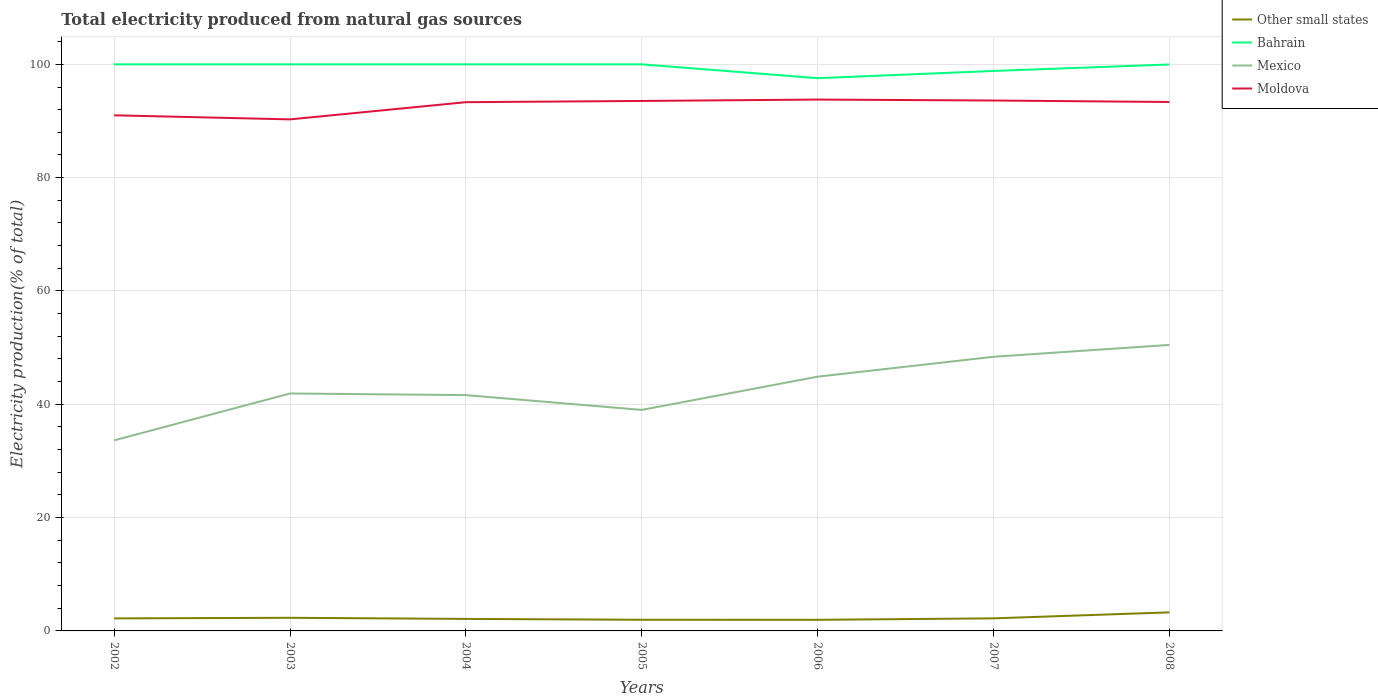Does the line corresponding to Bahrain intersect with the line corresponding to Moldova?
Offer a very short reply. No. Across all years, what is the maximum total electricity produced in Bahrain?
Your answer should be compact. 97.56. In which year was the total electricity produced in Other small states maximum?
Give a very brief answer. 2006. What is the total total electricity produced in Mexico in the graph?
Keep it short and to the point. -3.26. What is the difference between the highest and the second highest total electricity produced in Mexico?
Ensure brevity in your answer.  16.85. What is the difference between the highest and the lowest total electricity produced in Other small states?
Provide a succinct answer. 2. Is the total electricity produced in Bahrain strictly greater than the total electricity produced in Other small states over the years?
Your answer should be compact. No. How many years are there in the graph?
Provide a short and direct response. 7. Are the values on the major ticks of Y-axis written in scientific E-notation?
Your response must be concise. No. Does the graph contain any zero values?
Ensure brevity in your answer.  No. Where does the legend appear in the graph?
Provide a succinct answer. Top right. How many legend labels are there?
Make the answer very short. 4. How are the legend labels stacked?
Ensure brevity in your answer.  Vertical. What is the title of the graph?
Give a very brief answer. Total electricity produced from natural gas sources. Does "Zimbabwe" appear as one of the legend labels in the graph?
Your answer should be compact. No. What is the label or title of the X-axis?
Give a very brief answer. Years. What is the label or title of the Y-axis?
Ensure brevity in your answer.  Electricity production(% of total). What is the Electricity production(% of total) in Other small states in 2002?
Keep it short and to the point. 2.21. What is the Electricity production(% of total) of Bahrain in 2002?
Provide a short and direct response. 100. What is the Electricity production(% of total) of Mexico in 2002?
Give a very brief answer. 33.63. What is the Electricity production(% of total) in Moldova in 2002?
Your answer should be very brief. 91.01. What is the Electricity production(% of total) of Other small states in 2003?
Ensure brevity in your answer.  2.32. What is the Electricity production(% of total) in Bahrain in 2003?
Keep it short and to the point. 100. What is the Electricity production(% of total) in Mexico in 2003?
Ensure brevity in your answer.  41.91. What is the Electricity production(% of total) in Moldova in 2003?
Your answer should be very brief. 90.29. What is the Electricity production(% of total) in Other small states in 2004?
Give a very brief answer. 2.12. What is the Electricity production(% of total) in Mexico in 2004?
Keep it short and to the point. 41.62. What is the Electricity production(% of total) in Moldova in 2004?
Your answer should be very brief. 93.32. What is the Electricity production(% of total) of Other small states in 2005?
Give a very brief answer. 1.97. What is the Electricity production(% of total) in Mexico in 2005?
Give a very brief answer. 39.01. What is the Electricity production(% of total) in Moldova in 2005?
Make the answer very short. 93.54. What is the Electricity production(% of total) of Other small states in 2006?
Give a very brief answer. 1.96. What is the Electricity production(% of total) in Bahrain in 2006?
Ensure brevity in your answer.  97.56. What is the Electricity production(% of total) in Mexico in 2006?
Offer a terse response. 44.88. What is the Electricity production(% of total) of Moldova in 2006?
Provide a short and direct response. 93.78. What is the Electricity production(% of total) of Other small states in 2007?
Ensure brevity in your answer.  2.22. What is the Electricity production(% of total) of Bahrain in 2007?
Your response must be concise. 98.84. What is the Electricity production(% of total) of Mexico in 2007?
Your answer should be compact. 48.39. What is the Electricity production(% of total) in Moldova in 2007?
Provide a succinct answer. 93.62. What is the Electricity production(% of total) in Other small states in 2008?
Your answer should be compact. 3.28. What is the Electricity production(% of total) of Bahrain in 2008?
Keep it short and to the point. 99.98. What is the Electricity production(% of total) in Mexico in 2008?
Keep it short and to the point. 50.48. What is the Electricity production(% of total) of Moldova in 2008?
Keep it short and to the point. 93.36. Across all years, what is the maximum Electricity production(% of total) of Other small states?
Make the answer very short. 3.28. Across all years, what is the maximum Electricity production(% of total) in Mexico?
Provide a short and direct response. 50.48. Across all years, what is the maximum Electricity production(% of total) in Moldova?
Your answer should be compact. 93.78. Across all years, what is the minimum Electricity production(% of total) in Other small states?
Provide a short and direct response. 1.96. Across all years, what is the minimum Electricity production(% of total) in Bahrain?
Offer a very short reply. 97.56. Across all years, what is the minimum Electricity production(% of total) in Mexico?
Keep it short and to the point. 33.63. Across all years, what is the minimum Electricity production(% of total) in Moldova?
Give a very brief answer. 90.29. What is the total Electricity production(% of total) in Other small states in the graph?
Give a very brief answer. 16.07. What is the total Electricity production(% of total) in Bahrain in the graph?
Keep it short and to the point. 696.37. What is the total Electricity production(% of total) of Mexico in the graph?
Offer a terse response. 299.92. What is the total Electricity production(% of total) in Moldova in the graph?
Your response must be concise. 648.91. What is the difference between the Electricity production(% of total) of Other small states in 2002 and that in 2003?
Your answer should be compact. -0.1. What is the difference between the Electricity production(% of total) in Bahrain in 2002 and that in 2003?
Offer a very short reply. 0. What is the difference between the Electricity production(% of total) of Mexico in 2002 and that in 2003?
Keep it short and to the point. -8.28. What is the difference between the Electricity production(% of total) of Moldova in 2002 and that in 2003?
Ensure brevity in your answer.  0.72. What is the difference between the Electricity production(% of total) of Other small states in 2002 and that in 2004?
Your answer should be very brief. 0.09. What is the difference between the Electricity production(% of total) in Bahrain in 2002 and that in 2004?
Give a very brief answer. 0. What is the difference between the Electricity production(% of total) of Mexico in 2002 and that in 2004?
Make the answer very short. -7.98. What is the difference between the Electricity production(% of total) in Moldova in 2002 and that in 2004?
Provide a succinct answer. -2.32. What is the difference between the Electricity production(% of total) in Other small states in 2002 and that in 2005?
Your answer should be compact. 0.24. What is the difference between the Electricity production(% of total) of Mexico in 2002 and that in 2005?
Give a very brief answer. -5.38. What is the difference between the Electricity production(% of total) in Moldova in 2002 and that in 2005?
Your answer should be compact. -2.53. What is the difference between the Electricity production(% of total) in Other small states in 2002 and that in 2006?
Your answer should be compact. 0.25. What is the difference between the Electricity production(% of total) in Bahrain in 2002 and that in 2006?
Offer a very short reply. 2.44. What is the difference between the Electricity production(% of total) in Mexico in 2002 and that in 2006?
Keep it short and to the point. -11.24. What is the difference between the Electricity production(% of total) of Moldova in 2002 and that in 2006?
Offer a very short reply. -2.78. What is the difference between the Electricity production(% of total) of Other small states in 2002 and that in 2007?
Offer a terse response. -0.01. What is the difference between the Electricity production(% of total) of Bahrain in 2002 and that in 2007?
Your response must be concise. 1.16. What is the difference between the Electricity production(% of total) in Mexico in 2002 and that in 2007?
Provide a short and direct response. -14.75. What is the difference between the Electricity production(% of total) of Moldova in 2002 and that in 2007?
Your response must be concise. -2.61. What is the difference between the Electricity production(% of total) of Other small states in 2002 and that in 2008?
Your answer should be very brief. -1.06. What is the difference between the Electricity production(% of total) in Bahrain in 2002 and that in 2008?
Give a very brief answer. 0.02. What is the difference between the Electricity production(% of total) in Mexico in 2002 and that in 2008?
Give a very brief answer. -16.85. What is the difference between the Electricity production(% of total) in Moldova in 2002 and that in 2008?
Your answer should be very brief. -2.35. What is the difference between the Electricity production(% of total) in Other small states in 2003 and that in 2004?
Offer a terse response. 0.19. What is the difference between the Electricity production(% of total) of Mexico in 2003 and that in 2004?
Give a very brief answer. 0.29. What is the difference between the Electricity production(% of total) in Moldova in 2003 and that in 2004?
Provide a succinct answer. -3.04. What is the difference between the Electricity production(% of total) of Other small states in 2003 and that in 2005?
Offer a very short reply. 0.34. What is the difference between the Electricity production(% of total) of Bahrain in 2003 and that in 2005?
Make the answer very short. 0. What is the difference between the Electricity production(% of total) of Mexico in 2003 and that in 2005?
Offer a very short reply. 2.9. What is the difference between the Electricity production(% of total) of Moldova in 2003 and that in 2005?
Offer a very short reply. -3.25. What is the difference between the Electricity production(% of total) of Other small states in 2003 and that in 2006?
Keep it short and to the point. 0.35. What is the difference between the Electricity production(% of total) in Bahrain in 2003 and that in 2006?
Your answer should be compact. 2.44. What is the difference between the Electricity production(% of total) of Mexico in 2003 and that in 2006?
Your response must be concise. -2.96. What is the difference between the Electricity production(% of total) of Moldova in 2003 and that in 2006?
Provide a short and direct response. -3.5. What is the difference between the Electricity production(% of total) in Other small states in 2003 and that in 2007?
Ensure brevity in your answer.  0.1. What is the difference between the Electricity production(% of total) of Bahrain in 2003 and that in 2007?
Your response must be concise. 1.16. What is the difference between the Electricity production(% of total) in Mexico in 2003 and that in 2007?
Offer a very short reply. -6.48. What is the difference between the Electricity production(% of total) of Moldova in 2003 and that in 2007?
Provide a succinct answer. -3.33. What is the difference between the Electricity production(% of total) of Other small states in 2003 and that in 2008?
Provide a succinct answer. -0.96. What is the difference between the Electricity production(% of total) in Bahrain in 2003 and that in 2008?
Give a very brief answer. 0.02. What is the difference between the Electricity production(% of total) of Mexico in 2003 and that in 2008?
Keep it short and to the point. -8.57. What is the difference between the Electricity production(% of total) of Moldova in 2003 and that in 2008?
Your answer should be compact. -3.07. What is the difference between the Electricity production(% of total) of Other small states in 2004 and that in 2005?
Provide a short and direct response. 0.15. What is the difference between the Electricity production(% of total) in Mexico in 2004 and that in 2005?
Ensure brevity in your answer.  2.61. What is the difference between the Electricity production(% of total) in Moldova in 2004 and that in 2005?
Ensure brevity in your answer.  -0.22. What is the difference between the Electricity production(% of total) of Other small states in 2004 and that in 2006?
Make the answer very short. 0.16. What is the difference between the Electricity production(% of total) of Bahrain in 2004 and that in 2006?
Make the answer very short. 2.44. What is the difference between the Electricity production(% of total) of Mexico in 2004 and that in 2006?
Your answer should be very brief. -3.26. What is the difference between the Electricity production(% of total) of Moldova in 2004 and that in 2006?
Your answer should be compact. -0.46. What is the difference between the Electricity production(% of total) in Other small states in 2004 and that in 2007?
Provide a succinct answer. -0.1. What is the difference between the Electricity production(% of total) in Bahrain in 2004 and that in 2007?
Offer a very short reply. 1.16. What is the difference between the Electricity production(% of total) in Mexico in 2004 and that in 2007?
Your response must be concise. -6.77. What is the difference between the Electricity production(% of total) in Moldova in 2004 and that in 2007?
Provide a short and direct response. -0.29. What is the difference between the Electricity production(% of total) of Other small states in 2004 and that in 2008?
Give a very brief answer. -1.16. What is the difference between the Electricity production(% of total) of Bahrain in 2004 and that in 2008?
Make the answer very short. 0.02. What is the difference between the Electricity production(% of total) in Mexico in 2004 and that in 2008?
Make the answer very short. -8.86. What is the difference between the Electricity production(% of total) of Moldova in 2004 and that in 2008?
Offer a terse response. -0.03. What is the difference between the Electricity production(% of total) in Other small states in 2005 and that in 2006?
Offer a terse response. 0.01. What is the difference between the Electricity production(% of total) of Bahrain in 2005 and that in 2006?
Provide a short and direct response. 2.44. What is the difference between the Electricity production(% of total) in Mexico in 2005 and that in 2006?
Offer a terse response. -5.86. What is the difference between the Electricity production(% of total) in Moldova in 2005 and that in 2006?
Offer a very short reply. -0.24. What is the difference between the Electricity production(% of total) in Other small states in 2005 and that in 2007?
Your response must be concise. -0.25. What is the difference between the Electricity production(% of total) in Bahrain in 2005 and that in 2007?
Your answer should be very brief. 1.16. What is the difference between the Electricity production(% of total) of Mexico in 2005 and that in 2007?
Your response must be concise. -9.38. What is the difference between the Electricity production(% of total) in Moldova in 2005 and that in 2007?
Offer a very short reply. -0.08. What is the difference between the Electricity production(% of total) of Other small states in 2005 and that in 2008?
Offer a terse response. -1.31. What is the difference between the Electricity production(% of total) in Bahrain in 2005 and that in 2008?
Keep it short and to the point. 0.02. What is the difference between the Electricity production(% of total) of Mexico in 2005 and that in 2008?
Offer a very short reply. -11.47. What is the difference between the Electricity production(% of total) of Moldova in 2005 and that in 2008?
Make the answer very short. 0.18. What is the difference between the Electricity production(% of total) in Other small states in 2006 and that in 2007?
Make the answer very short. -0.26. What is the difference between the Electricity production(% of total) of Bahrain in 2006 and that in 2007?
Offer a terse response. -1.28. What is the difference between the Electricity production(% of total) in Mexico in 2006 and that in 2007?
Give a very brief answer. -3.51. What is the difference between the Electricity production(% of total) in Moldova in 2006 and that in 2007?
Ensure brevity in your answer.  0.17. What is the difference between the Electricity production(% of total) in Other small states in 2006 and that in 2008?
Your answer should be very brief. -1.31. What is the difference between the Electricity production(% of total) in Bahrain in 2006 and that in 2008?
Provide a succinct answer. -2.42. What is the difference between the Electricity production(% of total) in Mexico in 2006 and that in 2008?
Offer a very short reply. -5.61. What is the difference between the Electricity production(% of total) of Moldova in 2006 and that in 2008?
Provide a succinct answer. 0.43. What is the difference between the Electricity production(% of total) of Other small states in 2007 and that in 2008?
Make the answer very short. -1.06. What is the difference between the Electricity production(% of total) of Bahrain in 2007 and that in 2008?
Provide a succinct answer. -1.14. What is the difference between the Electricity production(% of total) of Mexico in 2007 and that in 2008?
Offer a very short reply. -2.1. What is the difference between the Electricity production(% of total) in Moldova in 2007 and that in 2008?
Give a very brief answer. 0.26. What is the difference between the Electricity production(% of total) of Other small states in 2002 and the Electricity production(% of total) of Bahrain in 2003?
Offer a very short reply. -97.79. What is the difference between the Electricity production(% of total) in Other small states in 2002 and the Electricity production(% of total) in Mexico in 2003?
Your response must be concise. -39.7. What is the difference between the Electricity production(% of total) of Other small states in 2002 and the Electricity production(% of total) of Moldova in 2003?
Provide a succinct answer. -88.07. What is the difference between the Electricity production(% of total) in Bahrain in 2002 and the Electricity production(% of total) in Mexico in 2003?
Keep it short and to the point. 58.09. What is the difference between the Electricity production(% of total) in Bahrain in 2002 and the Electricity production(% of total) in Moldova in 2003?
Give a very brief answer. 9.71. What is the difference between the Electricity production(% of total) of Mexico in 2002 and the Electricity production(% of total) of Moldova in 2003?
Keep it short and to the point. -56.65. What is the difference between the Electricity production(% of total) of Other small states in 2002 and the Electricity production(% of total) of Bahrain in 2004?
Ensure brevity in your answer.  -97.79. What is the difference between the Electricity production(% of total) of Other small states in 2002 and the Electricity production(% of total) of Mexico in 2004?
Provide a succinct answer. -39.41. What is the difference between the Electricity production(% of total) of Other small states in 2002 and the Electricity production(% of total) of Moldova in 2004?
Provide a succinct answer. -91.11. What is the difference between the Electricity production(% of total) in Bahrain in 2002 and the Electricity production(% of total) in Mexico in 2004?
Ensure brevity in your answer.  58.38. What is the difference between the Electricity production(% of total) of Bahrain in 2002 and the Electricity production(% of total) of Moldova in 2004?
Offer a very short reply. 6.68. What is the difference between the Electricity production(% of total) in Mexico in 2002 and the Electricity production(% of total) in Moldova in 2004?
Make the answer very short. -59.69. What is the difference between the Electricity production(% of total) of Other small states in 2002 and the Electricity production(% of total) of Bahrain in 2005?
Offer a terse response. -97.79. What is the difference between the Electricity production(% of total) of Other small states in 2002 and the Electricity production(% of total) of Mexico in 2005?
Offer a terse response. -36.8. What is the difference between the Electricity production(% of total) in Other small states in 2002 and the Electricity production(% of total) in Moldova in 2005?
Make the answer very short. -91.33. What is the difference between the Electricity production(% of total) in Bahrain in 2002 and the Electricity production(% of total) in Mexico in 2005?
Make the answer very short. 60.99. What is the difference between the Electricity production(% of total) in Bahrain in 2002 and the Electricity production(% of total) in Moldova in 2005?
Keep it short and to the point. 6.46. What is the difference between the Electricity production(% of total) in Mexico in 2002 and the Electricity production(% of total) in Moldova in 2005?
Ensure brevity in your answer.  -59.9. What is the difference between the Electricity production(% of total) of Other small states in 2002 and the Electricity production(% of total) of Bahrain in 2006?
Provide a short and direct response. -95.34. What is the difference between the Electricity production(% of total) in Other small states in 2002 and the Electricity production(% of total) in Mexico in 2006?
Provide a short and direct response. -42.66. What is the difference between the Electricity production(% of total) in Other small states in 2002 and the Electricity production(% of total) in Moldova in 2006?
Offer a terse response. -91.57. What is the difference between the Electricity production(% of total) in Bahrain in 2002 and the Electricity production(% of total) in Mexico in 2006?
Offer a terse response. 55.12. What is the difference between the Electricity production(% of total) of Bahrain in 2002 and the Electricity production(% of total) of Moldova in 2006?
Offer a terse response. 6.22. What is the difference between the Electricity production(% of total) of Mexico in 2002 and the Electricity production(% of total) of Moldova in 2006?
Your answer should be very brief. -60.15. What is the difference between the Electricity production(% of total) of Other small states in 2002 and the Electricity production(% of total) of Bahrain in 2007?
Your answer should be very brief. -96.62. What is the difference between the Electricity production(% of total) in Other small states in 2002 and the Electricity production(% of total) in Mexico in 2007?
Your answer should be very brief. -46.17. What is the difference between the Electricity production(% of total) of Other small states in 2002 and the Electricity production(% of total) of Moldova in 2007?
Make the answer very short. -91.4. What is the difference between the Electricity production(% of total) in Bahrain in 2002 and the Electricity production(% of total) in Mexico in 2007?
Offer a very short reply. 51.61. What is the difference between the Electricity production(% of total) in Bahrain in 2002 and the Electricity production(% of total) in Moldova in 2007?
Give a very brief answer. 6.38. What is the difference between the Electricity production(% of total) of Mexico in 2002 and the Electricity production(% of total) of Moldova in 2007?
Provide a succinct answer. -59.98. What is the difference between the Electricity production(% of total) in Other small states in 2002 and the Electricity production(% of total) in Bahrain in 2008?
Provide a succinct answer. -97.77. What is the difference between the Electricity production(% of total) of Other small states in 2002 and the Electricity production(% of total) of Mexico in 2008?
Your answer should be compact. -48.27. What is the difference between the Electricity production(% of total) of Other small states in 2002 and the Electricity production(% of total) of Moldova in 2008?
Provide a short and direct response. -91.14. What is the difference between the Electricity production(% of total) of Bahrain in 2002 and the Electricity production(% of total) of Mexico in 2008?
Your response must be concise. 49.52. What is the difference between the Electricity production(% of total) of Bahrain in 2002 and the Electricity production(% of total) of Moldova in 2008?
Your response must be concise. 6.64. What is the difference between the Electricity production(% of total) in Mexico in 2002 and the Electricity production(% of total) in Moldova in 2008?
Your response must be concise. -59.72. What is the difference between the Electricity production(% of total) of Other small states in 2003 and the Electricity production(% of total) of Bahrain in 2004?
Your answer should be very brief. -97.68. What is the difference between the Electricity production(% of total) in Other small states in 2003 and the Electricity production(% of total) in Mexico in 2004?
Offer a terse response. -39.3. What is the difference between the Electricity production(% of total) in Other small states in 2003 and the Electricity production(% of total) in Moldova in 2004?
Ensure brevity in your answer.  -91.01. What is the difference between the Electricity production(% of total) in Bahrain in 2003 and the Electricity production(% of total) in Mexico in 2004?
Your answer should be compact. 58.38. What is the difference between the Electricity production(% of total) in Bahrain in 2003 and the Electricity production(% of total) in Moldova in 2004?
Give a very brief answer. 6.68. What is the difference between the Electricity production(% of total) in Mexico in 2003 and the Electricity production(% of total) in Moldova in 2004?
Offer a very short reply. -51.41. What is the difference between the Electricity production(% of total) of Other small states in 2003 and the Electricity production(% of total) of Bahrain in 2005?
Make the answer very short. -97.68. What is the difference between the Electricity production(% of total) in Other small states in 2003 and the Electricity production(% of total) in Mexico in 2005?
Your response must be concise. -36.7. What is the difference between the Electricity production(% of total) in Other small states in 2003 and the Electricity production(% of total) in Moldova in 2005?
Keep it short and to the point. -91.22. What is the difference between the Electricity production(% of total) of Bahrain in 2003 and the Electricity production(% of total) of Mexico in 2005?
Your response must be concise. 60.99. What is the difference between the Electricity production(% of total) in Bahrain in 2003 and the Electricity production(% of total) in Moldova in 2005?
Make the answer very short. 6.46. What is the difference between the Electricity production(% of total) of Mexico in 2003 and the Electricity production(% of total) of Moldova in 2005?
Offer a terse response. -51.63. What is the difference between the Electricity production(% of total) in Other small states in 2003 and the Electricity production(% of total) in Bahrain in 2006?
Make the answer very short. -95.24. What is the difference between the Electricity production(% of total) of Other small states in 2003 and the Electricity production(% of total) of Mexico in 2006?
Your answer should be very brief. -42.56. What is the difference between the Electricity production(% of total) in Other small states in 2003 and the Electricity production(% of total) in Moldova in 2006?
Give a very brief answer. -91.47. What is the difference between the Electricity production(% of total) in Bahrain in 2003 and the Electricity production(% of total) in Mexico in 2006?
Provide a succinct answer. 55.12. What is the difference between the Electricity production(% of total) of Bahrain in 2003 and the Electricity production(% of total) of Moldova in 2006?
Provide a succinct answer. 6.22. What is the difference between the Electricity production(% of total) of Mexico in 2003 and the Electricity production(% of total) of Moldova in 2006?
Your answer should be compact. -51.87. What is the difference between the Electricity production(% of total) of Other small states in 2003 and the Electricity production(% of total) of Bahrain in 2007?
Ensure brevity in your answer.  -96.52. What is the difference between the Electricity production(% of total) in Other small states in 2003 and the Electricity production(% of total) in Mexico in 2007?
Offer a terse response. -46.07. What is the difference between the Electricity production(% of total) in Other small states in 2003 and the Electricity production(% of total) in Moldova in 2007?
Your answer should be very brief. -91.3. What is the difference between the Electricity production(% of total) of Bahrain in 2003 and the Electricity production(% of total) of Mexico in 2007?
Offer a very short reply. 51.61. What is the difference between the Electricity production(% of total) of Bahrain in 2003 and the Electricity production(% of total) of Moldova in 2007?
Your answer should be very brief. 6.38. What is the difference between the Electricity production(% of total) of Mexico in 2003 and the Electricity production(% of total) of Moldova in 2007?
Your answer should be compact. -51.71. What is the difference between the Electricity production(% of total) of Other small states in 2003 and the Electricity production(% of total) of Bahrain in 2008?
Make the answer very short. -97.66. What is the difference between the Electricity production(% of total) in Other small states in 2003 and the Electricity production(% of total) in Mexico in 2008?
Provide a short and direct response. -48.17. What is the difference between the Electricity production(% of total) of Other small states in 2003 and the Electricity production(% of total) of Moldova in 2008?
Offer a very short reply. -91.04. What is the difference between the Electricity production(% of total) of Bahrain in 2003 and the Electricity production(% of total) of Mexico in 2008?
Provide a short and direct response. 49.52. What is the difference between the Electricity production(% of total) in Bahrain in 2003 and the Electricity production(% of total) in Moldova in 2008?
Offer a terse response. 6.64. What is the difference between the Electricity production(% of total) of Mexico in 2003 and the Electricity production(% of total) of Moldova in 2008?
Your answer should be compact. -51.45. What is the difference between the Electricity production(% of total) of Other small states in 2004 and the Electricity production(% of total) of Bahrain in 2005?
Keep it short and to the point. -97.88. What is the difference between the Electricity production(% of total) of Other small states in 2004 and the Electricity production(% of total) of Mexico in 2005?
Make the answer very short. -36.89. What is the difference between the Electricity production(% of total) in Other small states in 2004 and the Electricity production(% of total) in Moldova in 2005?
Ensure brevity in your answer.  -91.42. What is the difference between the Electricity production(% of total) in Bahrain in 2004 and the Electricity production(% of total) in Mexico in 2005?
Make the answer very short. 60.99. What is the difference between the Electricity production(% of total) of Bahrain in 2004 and the Electricity production(% of total) of Moldova in 2005?
Make the answer very short. 6.46. What is the difference between the Electricity production(% of total) in Mexico in 2004 and the Electricity production(% of total) in Moldova in 2005?
Your answer should be very brief. -51.92. What is the difference between the Electricity production(% of total) of Other small states in 2004 and the Electricity production(% of total) of Bahrain in 2006?
Make the answer very short. -95.44. What is the difference between the Electricity production(% of total) in Other small states in 2004 and the Electricity production(% of total) in Mexico in 2006?
Your answer should be compact. -42.75. What is the difference between the Electricity production(% of total) of Other small states in 2004 and the Electricity production(% of total) of Moldova in 2006?
Your answer should be compact. -91.66. What is the difference between the Electricity production(% of total) of Bahrain in 2004 and the Electricity production(% of total) of Mexico in 2006?
Offer a very short reply. 55.12. What is the difference between the Electricity production(% of total) in Bahrain in 2004 and the Electricity production(% of total) in Moldova in 2006?
Provide a short and direct response. 6.22. What is the difference between the Electricity production(% of total) of Mexico in 2004 and the Electricity production(% of total) of Moldova in 2006?
Your answer should be compact. -52.16. What is the difference between the Electricity production(% of total) in Other small states in 2004 and the Electricity production(% of total) in Bahrain in 2007?
Make the answer very short. -96.71. What is the difference between the Electricity production(% of total) in Other small states in 2004 and the Electricity production(% of total) in Mexico in 2007?
Keep it short and to the point. -46.27. What is the difference between the Electricity production(% of total) of Other small states in 2004 and the Electricity production(% of total) of Moldova in 2007?
Your response must be concise. -91.5. What is the difference between the Electricity production(% of total) of Bahrain in 2004 and the Electricity production(% of total) of Mexico in 2007?
Give a very brief answer. 51.61. What is the difference between the Electricity production(% of total) of Bahrain in 2004 and the Electricity production(% of total) of Moldova in 2007?
Give a very brief answer. 6.38. What is the difference between the Electricity production(% of total) in Mexico in 2004 and the Electricity production(% of total) in Moldova in 2007?
Your answer should be compact. -52. What is the difference between the Electricity production(% of total) in Other small states in 2004 and the Electricity production(% of total) in Bahrain in 2008?
Make the answer very short. -97.86. What is the difference between the Electricity production(% of total) in Other small states in 2004 and the Electricity production(% of total) in Mexico in 2008?
Your answer should be compact. -48.36. What is the difference between the Electricity production(% of total) of Other small states in 2004 and the Electricity production(% of total) of Moldova in 2008?
Make the answer very short. -91.24. What is the difference between the Electricity production(% of total) in Bahrain in 2004 and the Electricity production(% of total) in Mexico in 2008?
Keep it short and to the point. 49.52. What is the difference between the Electricity production(% of total) in Bahrain in 2004 and the Electricity production(% of total) in Moldova in 2008?
Your response must be concise. 6.64. What is the difference between the Electricity production(% of total) in Mexico in 2004 and the Electricity production(% of total) in Moldova in 2008?
Offer a very short reply. -51.74. What is the difference between the Electricity production(% of total) in Other small states in 2005 and the Electricity production(% of total) in Bahrain in 2006?
Provide a short and direct response. -95.59. What is the difference between the Electricity production(% of total) in Other small states in 2005 and the Electricity production(% of total) in Mexico in 2006?
Offer a terse response. -42.9. What is the difference between the Electricity production(% of total) of Other small states in 2005 and the Electricity production(% of total) of Moldova in 2006?
Your response must be concise. -91.81. What is the difference between the Electricity production(% of total) in Bahrain in 2005 and the Electricity production(% of total) in Mexico in 2006?
Your answer should be very brief. 55.12. What is the difference between the Electricity production(% of total) in Bahrain in 2005 and the Electricity production(% of total) in Moldova in 2006?
Give a very brief answer. 6.22. What is the difference between the Electricity production(% of total) of Mexico in 2005 and the Electricity production(% of total) of Moldova in 2006?
Your answer should be compact. -54.77. What is the difference between the Electricity production(% of total) of Other small states in 2005 and the Electricity production(% of total) of Bahrain in 2007?
Provide a succinct answer. -96.87. What is the difference between the Electricity production(% of total) of Other small states in 2005 and the Electricity production(% of total) of Mexico in 2007?
Your response must be concise. -46.42. What is the difference between the Electricity production(% of total) of Other small states in 2005 and the Electricity production(% of total) of Moldova in 2007?
Give a very brief answer. -91.65. What is the difference between the Electricity production(% of total) in Bahrain in 2005 and the Electricity production(% of total) in Mexico in 2007?
Ensure brevity in your answer.  51.61. What is the difference between the Electricity production(% of total) of Bahrain in 2005 and the Electricity production(% of total) of Moldova in 2007?
Your response must be concise. 6.38. What is the difference between the Electricity production(% of total) in Mexico in 2005 and the Electricity production(% of total) in Moldova in 2007?
Offer a terse response. -54.61. What is the difference between the Electricity production(% of total) in Other small states in 2005 and the Electricity production(% of total) in Bahrain in 2008?
Ensure brevity in your answer.  -98.01. What is the difference between the Electricity production(% of total) of Other small states in 2005 and the Electricity production(% of total) of Mexico in 2008?
Offer a terse response. -48.51. What is the difference between the Electricity production(% of total) of Other small states in 2005 and the Electricity production(% of total) of Moldova in 2008?
Provide a succinct answer. -91.39. What is the difference between the Electricity production(% of total) in Bahrain in 2005 and the Electricity production(% of total) in Mexico in 2008?
Provide a short and direct response. 49.52. What is the difference between the Electricity production(% of total) of Bahrain in 2005 and the Electricity production(% of total) of Moldova in 2008?
Provide a succinct answer. 6.64. What is the difference between the Electricity production(% of total) in Mexico in 2005 and the Electricity production(% of total) in Moldova in 2008?
Keep it short and to the point. -54.35. What is the difference between the Electricity production(% of total) in Other small states in 2006 and the Electricity production(% of total) in Bahrain in 2007?
Give a very brief answer. -96.87. What is the difference between the Electricity production(% of total) in Other small states in 2006 and the Electricity production(% of total) in Mexico in 2007?
Your answer should be compact. -46.42. What is the difference between the Electricity production(% of total) in Other small states in 2006 and the Electricity production(% of total) in Moldova in 2007?
Your answer should be very brief. -91.66. What is the difference between the Electricity production(% of total) of Bahrain in 2006 and the Electricity production(% of total) of Mexico in 2007?
Your answer should be very brief. 49.17. What is the difference between the Electricity production(% of total) in Bahrain in 2006 and the Electricity production(% of total) in Moldova in 2007?
Provide a short and direct response. 3.94. What is the difference between the Electricity production(% of total) in Mexico in 2006 and the Electricity production(% of total) in Moldova in 2007?
Keep it short and to the point. -48.74. What is the difference between the Electricity production(% of total) in Other small states in 2006 and the Electricity production(% of total) in Bahrain in 2008?
Your answer should be compact. -98.02. What is the difference between the Electricity production(% of total) of Other small states in 2006 and the Electricity production(% of total) of Mexico in 2008?
Keep it short and to the point. -48.52. What is the difference between the Electricity production(% of total) in Other small states in 2006 and the Electricity production(% of total) in Moldova in 2008?
Ensure brevity in your answer.  -91.4. What is the difference between the Electricity production(% of total) in Bahrain in 2006 and the Electricity production(% of total) in Mexico in 2008?
Your answer should be compact. 47.07. What is the difference between the Electricity production(% of total) of Bahrain in 2006 and the Electricity production(% of total) of Moldova in 2008?
Provide a short and direct response. 4.2. What is the difference between the Electricity production(% of total) in Mexico in 2006 and the Electricity production(% of total) in Moldova in 2008?
Keep it short and to the point. -48.48. What is the difference between the Electricity production(% of total) of Other small states in 2007 and the Electricity production(% of total) of Bahrain in 2008?
Give a very brief answer. -97.76. What is the difference between the Electricity production(% of total) in Other small states in 2007 and the Electricity production(% of total) in Mexico in 2008?
Your answer should be very brief. -48.26. What is the difference between the Electricity production(% of total) in Other small states in 2007 and the Electricity production(% of total) in Moldova in 2008?
Offer a very short reply. -91.14. What is the difference between the Electricity production(% of total) of Bahrain in 2007 and the Electricity production(% of total) of Mexico in 2008?
Give a very brief answer. 48.35. What is the difference between the Electricity production(% of total) in Bahrain in 2007 and the Electricity production(% of total) in Moldova in 2008?
Make the answer very short. 5.48. What is the difference between the Electricity production(% of total) of Mexico in 2007 and the Electricity production(% of total) of Moldova in 2008?
Offer a very short reply. -44.97. What is the average Electricity production(% of total) of Other small states per year?
Make the answer very short. 2.3. What is the average Electricity production(% of total) in Bahrain per year?
Your answer should be compact. 99.48. What is the average Electricity production(% of total) of Mexico per year?
Provide a short and direct response. 42.85. What is the average Electricity production(% of total) of Moldova per year?
Make the answer very short. 92.7. In the year 2002, what is the difference between the Electricity production(% of total) of Other small states and Electricity production(% of total) of Bahrain?
Keep it short and to the point. -97.79. In the year 2002, what is the difference between the Electricity production(% of total) in Other small states and Electricity production(% of total) in Mexico?
Ensure brevity in your answer.  -31.42. In the year 2002, what is the difference between the Electricity production(% of total) of Other small states and Electricity production(% of total) of Moldova?
Provide a short and direct response. -88.79. In the year 2002, what is the difference between the Electricity production(% of total) in Bahrain and Electricity production(% of total) in Mexico?
Your answer should be very brief. 66.37. In the year 2002, what is the difference between the Electricity production(% of total) in Bahrain and Electricity production(% of total) in Moldova?
Your response must be concise. 8.99. In the year 2002, what is the difference between the Electricity production(% of total) in Mexico and Electricity production(% of total) in Moldova?
Provide a succinct answer. -57.37. In the year 2003, what is the difference between the Electricity production(% of total) in Other small states and Electricity production(% of total) in Bahrain?
Give a very brief answer. -97.68. In the year 2003, what is the difference between the Electricity production(% of total) of Other small states and Electricity production(% of total) of Mexico?
Your answer should be very brief. -39.6. In the year 2003, what is the difference between the Electricity production(% of total) in Other small states and Electricity production(% of total) in Moldova?
Give a very brief answer. -87.97. In the year 2003, what is the difference between the Electricity production(% of total) in Bahrain and Electricity production(% of total) in Mexico?
Your answer should be compact. 58.09. In the year 2003, what is the difference between the Electricity production(% of total) of Bahrain and Electricity production(% of total) of Moldova?
Your answer should be compact. 9.71. In the year 2003, what is the difference between the Electricity production(% of total) of Mexico and Electricity production(% of total) of Moldova?
Your response must be concise. -48.38. In the year 2004, what is the difference between the Electricity production(% of total) of Other small states and Electricity production(% of total) of Bahrain?
Provide a short and direct response. -97.88. In the year 2004, what is the difference between the Electricity production(% of total) of Other small states and Electricity production(% of total) of Mexico?
Provide a succinct answer. -39.5. In the year 2004, what is the difference between the Electricity production(% of total) of Other small states and Electricity production(% of total) of Moldova?
Keep it short and to the point. -91.2. In the year 2004, what is the difference between the Electricity production(% of total) of Bahrain and Electricity production(% of total) of Mexico?
Give a very brief answer. 58.38. In the year 2004, what is the difference between the Electricity production(% of total) of Bahrain and Electricity production(% of total) of Moldova?
Your answer should be compact. 6.68. In the year 2004, what is the difference between the Electricity production(% of total) of Mexico and Electricity production(% of total) of Moldova?
Offer a terse response. -51.7. In the year 2005, what is the difference between the Electricity production(% of total) in Other small states and Electricity production(% of total) in Bahrain?
Give a very brief answer. -98.03. In the year 2005, what is the difference between the Electricity production(% of total) of Other small states and Electricity production(% of total) of Mexico?
Keep it short and to the point. -37.04. In the year 2005, what is the difference between the Electricity production(% of total) in Other small states and Electricity production(% of total) in Moldova?
Offer a terse response. -91.57. In the year 2005, what is the difference between the Electricity production(% of total) in Bahrain and Electricity production(% of total) in Mexico?
Your response must be concise. 60.99. In the year 2005, what is the difference between the Electricity production(% of total) in Bahrain and Electricity production(% of total) in Moldova?
Your response must be concise. 6.46. In the year 2005, what is the difference between the Electricity production(% of total) of Mexico and Electricity production(% of total) of Moldova?
Give a very brief answer. -54.53. In the year 2006, what is the difference between the Electricity production(% of total) in Other small states and Electricity production(% of total) in Bahrain?
Your response must be concise. -95.6. In the year 2006, what is the difference between the Electricity production(% of total) in Other small states and Electricity production(% of total) in Mexico?
Provide a short and direct response. -42.91. In the year 2006, what is the difference between the Electricity production(% of total) of Other small states and Electricity production(% of total) of Moldova?
Ensure brevity in your answer.  -91.82. In the year 2006, what is the difference between the Electricity production(% of total) in Bahrain and Electricity production(% of total) in Mexico?
Provide a succinct answer. 52.68. In the year 2006, what is the difference between the Electricity production(% of total) of Bahrain and Electricity production(% of total) of Moldova?
Ensure brevity in your answer.  3.77. In the year 2006, what is the difference between the Electricity production(% of total) in Mexico and Electricity production(% of total) in Moldova?
Keep it short and to the point. -48.91. In the year 2007, what is the difference between the Electricity production(% of total) in Other small states and Electricity production(% of total) in Bahrain?
Provide a short and direct response. -96.62. In the year 2007, what is the difference between the Electricity production(% of total) of Other small states and Electricity production(% of total) of Mexico?
Provide a short and direct response. -46.17. In the year 2007, what is the difference between the Electricity production(% of total) in Other small states and Electricity production(% of total) in Moldova?
Offer a very short reply. -91.4. In the year 2007, what is the difference between the Electricity production(% of total) of Bahrain and Electricity production(% of total) of Mexico?
Provide a short and direct response. 50.45. In the year 2007, what is the difference between the Electricity production(% of total) of Bahrain and Electricity production(% of total) of Moldova?
Ensure brevity in your answer.  5.22. In the year 2007, what is the difference between the Electricity production(% of total) of Mexico and Electricity production(% of total) of Moldova?
Make the answer very short. -45.23. In the year 2008, what is the difference between the Electricity production(% of total) of Other small states and Electricity production(% of total) of Bahrain?
Ensure brevity in your answer.  -96.7. In the year 2008, what is the difference between the Electricity production(% of total) of Other small states and Electricity production(% of total) of Mexico?
Give a very brief answer. -47.21. In the year 2008, what is the difference between the Electricity production(% of total) of Other small states and Electricity production(% of total) of Moldova?
Your response must be concise. -90.08. In the year 2008, what is the difference between the Electricity production(% of total) in Bahrain and Electricity production(% of total) in Mexico?
Provide a succinct answer. 49.5. In the year 2008, what is the difference between the Electricity production(% of total) in Bahrain and Electricity production(% of total) in Moldova?
Your response must be concise. 6.62. In the year 2008, what is the difference between the Electricity production(% of total) of Mexico and Electricity production(% of total) of Moldova?
Your response must be concise. -42.88. What is the ratio of the Electricity production(% of total) of Other small states in 2002 to that in 2003?
Provide a succinct answer. 0.96. What is the ratio of the Electricity production(% of total) of Bahrain in 2002 to that in 2003?
Your answer should be very brief. 1. What is the ratio of the Electricity production(% of total) in Mexico in 2002 to that in 2003?
Ensure brevity in your answer.  0.8. What is the ratio of the Electricity production(% of total) in Moldova in 2002 to that in 2003?
Give a very brief answer. 1.01. What is the ratio of the Electricity production(% of total) of Other small states in 2002 to that in 2004?
Your response must be concise. 1.04. What is the ratio of the Electricity production(% of total) of Mexico in 2002 to that in 2004?
Your answer should be compact. 0.81. What is the ratio of the Electricity production(% of total) in Moldova in 2002 to that in 2004?
Keep it short and to the point. 0.98. What is the ratio of the Electricity production(% of total) in Other small states in 2002 to that in 2005?
Offer a very short reply. 1.12. What is the ratio of the Electricity production(% of total) in Bahrain in 2002 to that in 2005?
Offer a terse response. 1. What is the ratio of the Electricity production(% of total) in Mexico in 2002 to that in 2005?
Give a very brief answer. 0.86. What is the ratio of the Electricity production(% of total) of Moldova in 2002 to that in 2005?
Provide a short and direct response. 0.97. What is the ratio of the Electricity production(% of total) in Other small states in 2002 to that in 2006?
Give a very brief answer. 1.13. What is the ratio of the Electricity production(% of total) of Bahrain in 2002 to that in 2006?
Offer a terse response. 1.02. What is the ratio of the Electricity production(% of total) in Mexico in 2002 to that in 2006?
Ensure brevity in your answer.  0.75. What is the ratio of the Electricity production(% of total) of Moldova in 2002 to that in 2006?
Give a very brief answer. 0.97. What is the ratio of the Electricity production(% of total) of Other small states in 2002 to that in 2007?
Provide a succinct answer. 1. What is the ratio of the Electricity production(% of total) of Bahrain in 2002 to that in 2007?
Your answer should be very brief. 1.01. What is the ratio of the Electricity production(% of total) in Mexico in 2002 to that in 2007?
Keep it short and to the point. 0.7. What is the ratio of the Electricity production(% of total) in Moldova in 2002 to that in 2007?
Give a very brief answer. 0.97. What is the ratio of the Electricity production(% of total) of Other small states in 2002 to that in 2008?
Your answer should be very brief. 0.68. What is the ratio of the Electricity production(% of total) of Bahrain in 2002 to that in 2008?
Ensure brevity in your answer.  1. What is the ratio of the Electricity production(% of total) in Mexico in 2002 to that in 2008?
Ensure brevity in your answer.  0.67. What is the ratio of the Electricity production(% of total) in Moldova in 2002 to that in 2008?
Make the answer very short. 0.97. What is the ratio of the Electricity production(% of total) of Other small states in 2003 to that in 2004?
Your response must be concise. 1.09. What is the ratio of the Electricity production(% of total) in Mexico in 2003 to that in 2004?
Ensure brevity in your answer.  1.01. What is the ratio of the Electricity production(% of total) in Moldova in 2003 to that in 2004?
Offer a terse response. 0.97. What is the ratio of the Electricity production(% of total) in Other small states in 2003 to that in 2005?
Provide a short and direct response. 1.18. What is the ratio of the Electricity production(% of total) of Mexico in 2003 to that in 2005?
Provide a succinct answer. 1.07. What is the ratio of the Electricity production(% of total) of Moldova in 2003 to that in 2005?
Give a very brief answer. 0.97. What is the ratio of the Electricity production(% of total) of Other small states in 2003 to that in 2006?
Provide a succinct answer. 1.18. What is the ratio of the Electricity production(% of total) in Bahrain in 2003 to that in 2006?
Ensure brevity in your answer.  1.02. What is the ratio of the Electricity production(% of total) in Mexico in 2003 to that in 2006?
Ensure brevity in your answer.  0.93. What is the ratio of the Electricity production(% of total) in Moldova in 2003 to that in 2006?
Offer a very short reply. 0.96. What is the ratio of the Electricity production(% of total) in Other small states in 2003 to that in 2007?
Provide a succinct answer. 1.04. What is the ratio of the Electricity production(% of total) of Bahrain in 2003 to that in 2007?
Make the answer very short. 1.01. What is the ratio of the Electricity production(% of total) in Mexico in 2003 to that in 2007?
Give a very brief answer. 0.87. What is the ratio of the Electricity production(% of total) of Moldova in 2003 to that in 2007?
Offer a terse response. 0.96. What is the ratio of the Electricity production(% of total) of Other small states in 2003 to that in 2008?
Make the answer very short. 0.71. What is the ratio of the Electricity production(% of total) of Mexico in 2003 to that in 2008?
Your answer should be very brief. 0.83. What is the ratio of the Electricity production(% of total) of Moldova in 2003 to that in 2008?
Your answer should be very brief. 0.97. What is the ratio of the Electricity production(% of total) of Other small states in 2004 to that in 2005?
Your answer should be very brief. 1.08. What is the ratio of the Electricity production(% of total) in Bahrain in 2004 to that in 2005?
Provide a short and direct response. 1. What is the ratio of the Electricity production(% of total) of Mexico in 2004 to that in 2005?
Make the answer very short. 1.07. What is the ratio of the Electricity production(% of total) in Other small states in 2004 to that in 2006?
Your answer should be very brief. 1.08. What is the ratio of the Electricity production(% of total) of Mexico in 2004 to that in 2006?
Your response must be concise. 0.93. What is the ratio of the Electricity production(% of total) of Moldova in 2004 to that in 2006?
Offer a very short reply. 1. What is the ratio of the Electricity production(% of total) in Other small states in 2004 to that in 2007?
Make the answer very short. 0.96. What is the ratio of the Electricity production(% of total) in Bahrain in 2004 to that in 2007?
Ensure brevity in your answer.  1.01. What is the ratio of the Electricity production(% of total) in Mexico in 2004 to that in 2007?
Provide a short and direct response. 0.86. What is the ratio of the Electricity production(% of total) in Moldova in 2004 to that in 2007?
Your response must be concise. 1. What is the ratio of the Electricity production(% of total) of Other small states in 2004 to that in 2008?
Your answer should be compact. 0.65. What is the ratio of the Electricity production(% of total) of Bahrain in 2004 to that in 2008?
Ensure brevity in your answer.  1. What is the ratio of the Electricity production(% of total) in Mexico in 2004 to that in 2008?
Provide a short and direct response. 0.82. What is the ratio of the Electricity production(% of total) of Mexico in 2005 to that in 2006?
Offer a terse response. 0.87. What is the ratio of the Electricity production(% of total) in Other small states in 2005 to that in 2007?
Your response must be concise. 0.89. What is the ratio of the Electricity production(% of total) of Bahrain in 2005 to that in 2007?
Your response must be concise. 1.01. What is the ratio of the Electricity production(% of total) of Mexico in 2005 to that in 2007?
Make the answer very short. 0.81. What is the ratio of the Electricity production(% of total) in Moldova in 2005 to that in 2007?
Provide a short and direct response. 1. What is the ratio of the Electricity production(% of total) of Other small states in 2005 to that in 2008?
Offer a very short reply. 0.6. What is the ratio of the Electricity production(% of total) of Bahrain in 2005 to that in 2008?
Your answer should be very brief. 1. What is the ratio of the Electricity production(% of total) in Mexico in 2005 to that in 2008?
Provide a short and direct response. 0.77. What is the ratio of the Electricity production(% of total) of Other small states in 2006 to that in 2007?
Offer a very short reply. 0.88. What is the ratio of the Electricity production(% of total) of Bahrain in 2006 to that in 2007?
Give a very brief answer. 0.99. What is the ratio of the Electricity production(% of total) in Mexico in 2006 to that in 2007?
Make the answer very short. 0.93. What is the ratio of the Electricity production(% of total) in Moldova in 2006 to that in 2007?
Give a very brief answer. 1. What is the ratio of the Electricity production(% of total) of Other small states in 2006 to that in 2008?
Your answer should be compact. 0.6. What is the ratio of the Electricity production(% of total) in Bahrain in 2006 to that in 2008?
Ensure brevity in your answer.  0.98. What is the ratio of the Electricity production(% of total) in Moldova in 2006 to that in 2008?
Your answer should be very brief. 1. What is the ratio of the Electricity production(% of total) of Other small states in 2007 to that in 2008?
Ensure brevity in your answer.  0.68. What is the ratio of the Electricity production(% of total) in Mexico in 2007 to that in 2008?
Provide a succinct answer. 0.96. What is the ratio of the Electricity production(% of total) of Moldova in 2007 to that in 2008?
Keep it short and to the point. 1. What is the difference between the highest and the second highest Electricity production(% of total) of Other small states?
Offer a very short reply. 0.96. What is the difference between the highest and the second highest Electricity production(% of total) in Mexico?
Provide a short and direct response. 2.1. What is the difference between the highest and the second highest Electricity production(% of total) in Moldova?
Offer a terse response. 0.17. What is the difference between the highest and the lowest Electricity production(% of total) in Other small states?
Provide a succinct answer. 1.31. What is the difference between the highest and the lowest Electricity production(% of total) of Bahrain?
Make the answer very short. 2.44. What is the difference between the highest and the lowest Electricity production(% of total) in Mexico?
Your answer should be very brief. 16.85. What is the difference between the highest and the lowest Electricity production(% of total) of Moldova?
Your answer should be very brief. 3.5. 